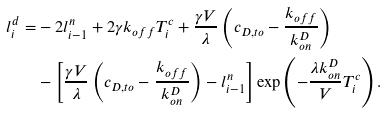<formula> <loc_0><loc_0><loc_500><loc_500>l ^ { d } _ { i } = & - 2 l ^ { n } _ { i - 1 } + 2 \gamma k _ { o f f } T ^ { c } _ { i } + \frac { \gamma V } { \lambda } \left ( c _ { D , t o } - \frac { k _ { o f f } } { k _ { o n } ^ { D } } \right ) \\ & - \left [ \frac { \gamma V } { \lambda } \left ( c _ { D , t o } - \frac { k _ { o f f } } { k _ { o n } ^ { D } } \right ) - l ^ { n } _ { i - 1 } \right ] \exp \left ( - \frac { \lambda k _ { o n } ^ { D } } { V } T ^ { c } _ { i } \right ) .</formula> 